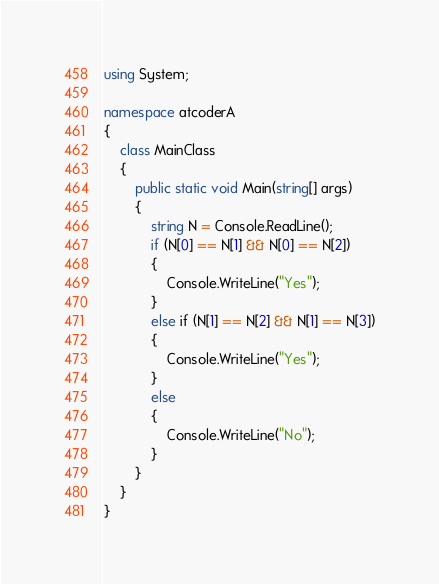Convert code to text. <code><loc_0><loc_0><loc_500><loc_500><_C#_>using System;

namespace atcoderA
{
    class MainClass
    {
        public static void Main(string[] args)
        {
            string N = Console.ReadLine();
            if (N[0] == N[1] && N[0] == N[2])
            {
                Console.WriteLine("Yes");
            }
            else if (N[1] == N[2] && N[1] == N[3])
            {
                Console.WriteLine("Yes");
            }
            else
            {
                Console.WriteLine("No");
            }
        }
    }
}</code> 